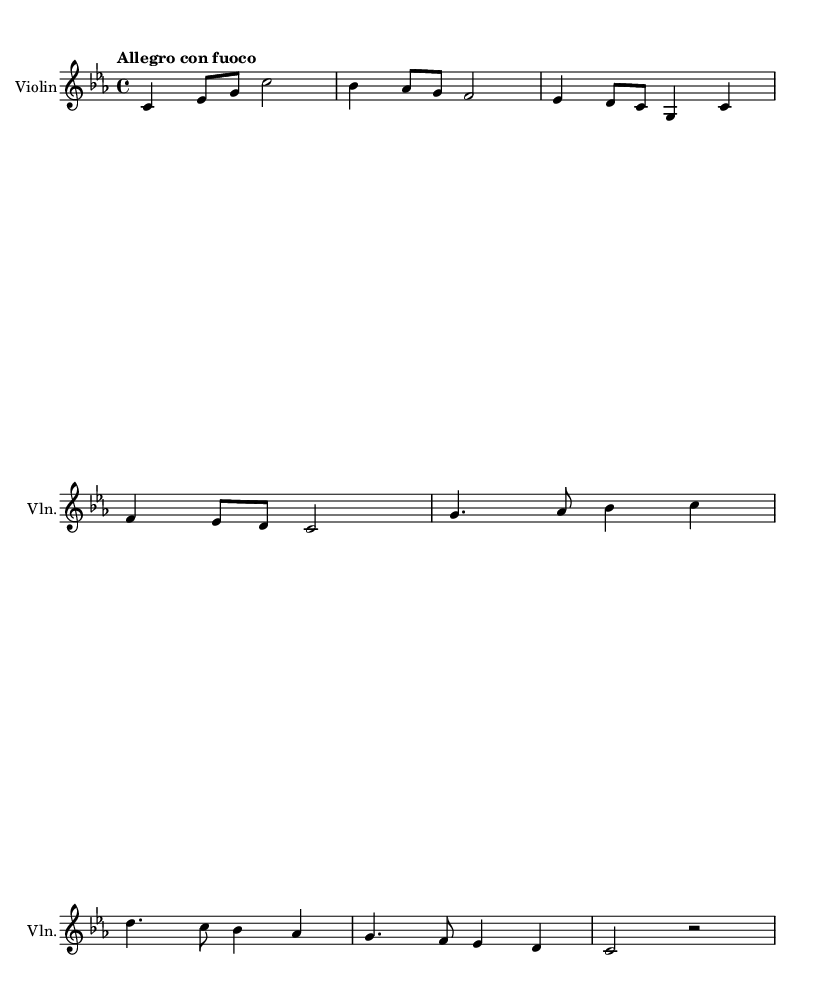What is the key signature of this music? The key signature is C minor, which is indicated by the presence of three flats (B flat, E flat, and A flat) found at the beginning of the staff.
Answer: C minor What is the time signature of this music? The time signature is 4/4, which is noted at the start of the piece and indicates four beats per measure with the quarter note getting one beat.
Answer: 4/4 What is the tempo marking for this music? The tempo marking is "Allegro con fuoco", which suggests a fast tempo with a sense of fire or intensity. This is typically found at the beginning of the score.
Answer: Allegro con fuoco How many measures are in the main theme? The main theme consists of four measures, which are clearly divided by the vertical bar lines in the notation.
Answer: 4 Which instrument is featured in this score? The instrument specifically mentioned in the score is the Violin, indicated at the top of the staff where the instrument name is printed.
Answer: Violin What is the total number of distinct themes presented in this piece? There are two distinct themes presented in this piece, labeled as the main theme and the secondary theme, which are indicated in the score.
Answer: 2 themes What is the first note of the secondary theme? The first note of the secondary theme is G, which is the first note in the corresponding musical section appearing on the staff.
Answer: G 